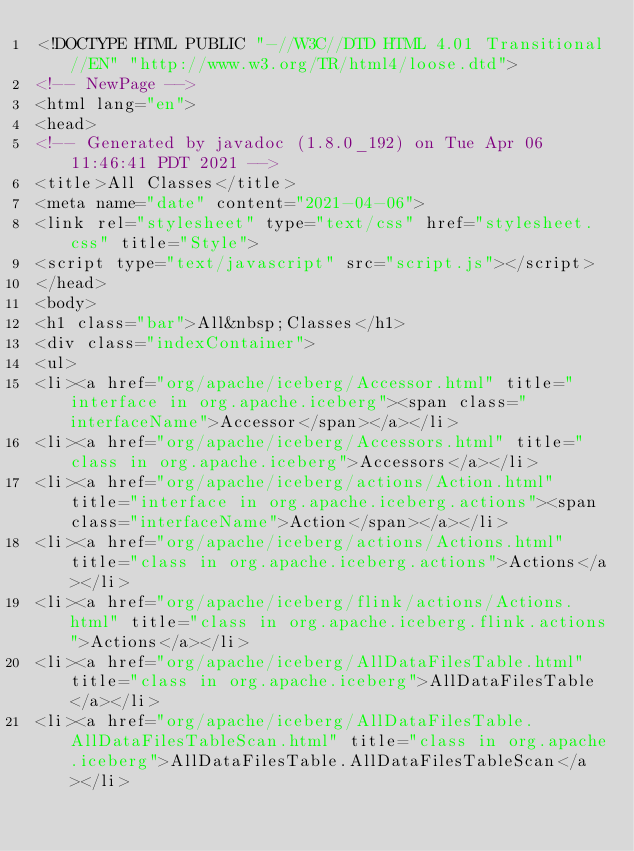<code> <loc_0><loc_0><loc_500><loc_500><_HTML_><!DOCTYPE HTML PUBLIC "-//W3C//DTD HTML 4.01 Transitional//EN" "http://www.w3.org/TR/html4/loose.dtd">
<!-- NewPage -->
<html lang="en">
<head>
<!-- Generated by javadoc (1.8.0_192) on Tue Apr 06 11:46:41 PDT 2021 -->
<title>All Classes</title>
<meta name="date" content="2021-04-06">
<link rel="stylesheet" type="text/css" href="stylesheet.css" title="Style">
<script type="text/javascript" src="script.js"></script>
</head>
<body>
<h1 class="bar">All&nbsp;Classes</h1>
<div class="indexContainer">
<ul>
<li><a href="org/apache/iceberg/Accessor.html" title="interface in org.apache.iceberg"><span class="interfaceName">Accessor</span></a></li>
<li><a href="org/apache/iceberg/Accessors.html" title="class in org.apache.iceberg">Accessors</a></li>
<li><a href="org/apache/iceberg/actions/Action.html" title="interface in org.apache.iceberg.actions"><span class="interfaceName">Action</span></a></li>
<li><a href="org/apache/iceberg/actions/Actions.html" title="class in org.apache.iceberg.actions">Actions</a></li>
<li><a href="org/apache/iceberg/flink/actions/Actions.html" title="class in org.apache.iceberg.flink.actions">Actions</a></li>
<li><a href="org/apache/iceberg/AllDataFilesTable.html" title="class in org.apache.iceberg">AllDataFilesTable</a></li>
<li><a href="org/apache/iceberg/AllDataFilesTable.AllDataFilesTableScan.html" title="class in org.apache.iceberg">AllDataFilesTable.AllDataFilesTableScan</a></li></code> 